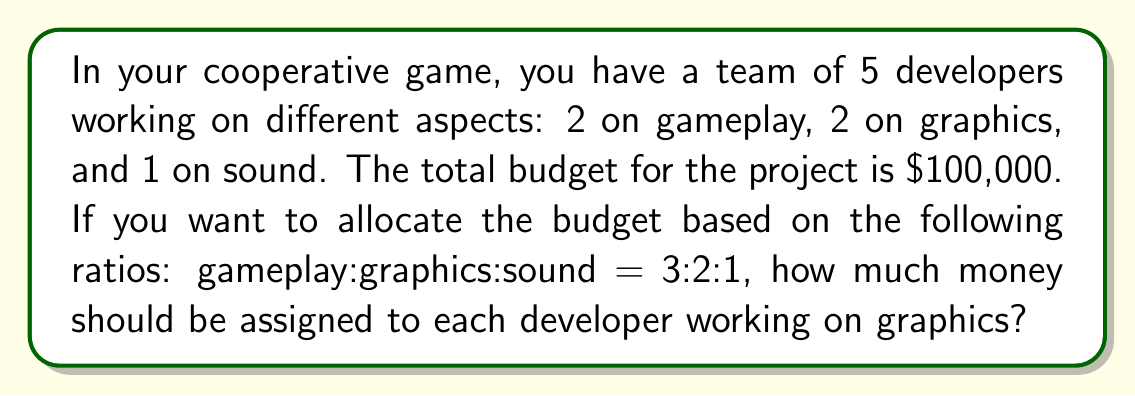Help me with this question. Let's solve this step-by-step:

1. First, we need to determine the total parts in the ratio:
   Gameplay: 3 parts
   Graphics: 2 parts
   Sound: 1 part
   Total parts = 3 + 2 + 1 = 6 parts

2. Calculate the value of each part:
   $\frac{\text{Total budget}}{\text{Total parts}} = \frac{\$100,000}{6} = \$16,666.67$ per part

3. Calculate the budget for each aspect:
   Gameplay: $3 \times \$16,666.67 = \$50,000$
   Graphics: $2 \times \$16,666.67 = \$33,333.33$
   Sound: $1 \times \$16,666.67 = \$16,666.67$

4. Since there are 2 developers working on graphics, we need to divide the graphics budget by 2:
   $\frac{\$33,333.33}{2} = \$16,666.67$ per graphics developer

Therefore, each developer working on graphics should be assigned $16,666.67.
Answer: $16,666.67 